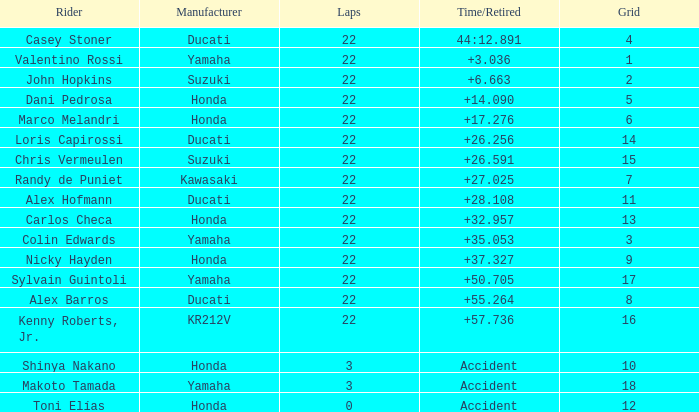What is the average grid for the competitiors who had laps smaller than 3? 12.0. 